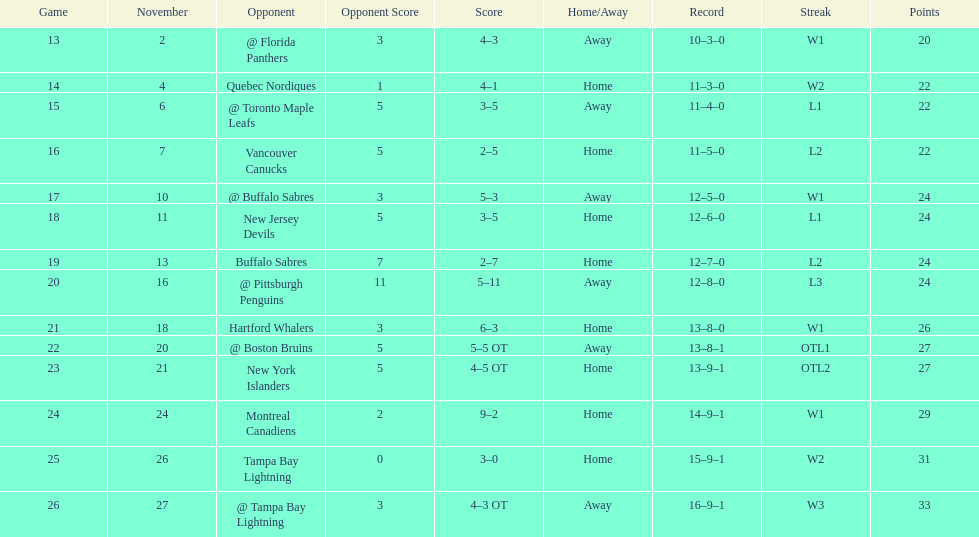Did the tampa bay lightning have the least amount of wins? Yes. 